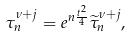Convert formula to latex. <formula><loc_0><loc_0><loc_500><loc_500>\tau _ { n } ^ { \nu + j } = e ^ { n \frac { t ^ { 2 } } { 4 } } \widetilde { \tau } _ { n } ^ { \nu + j } ,</formula> 